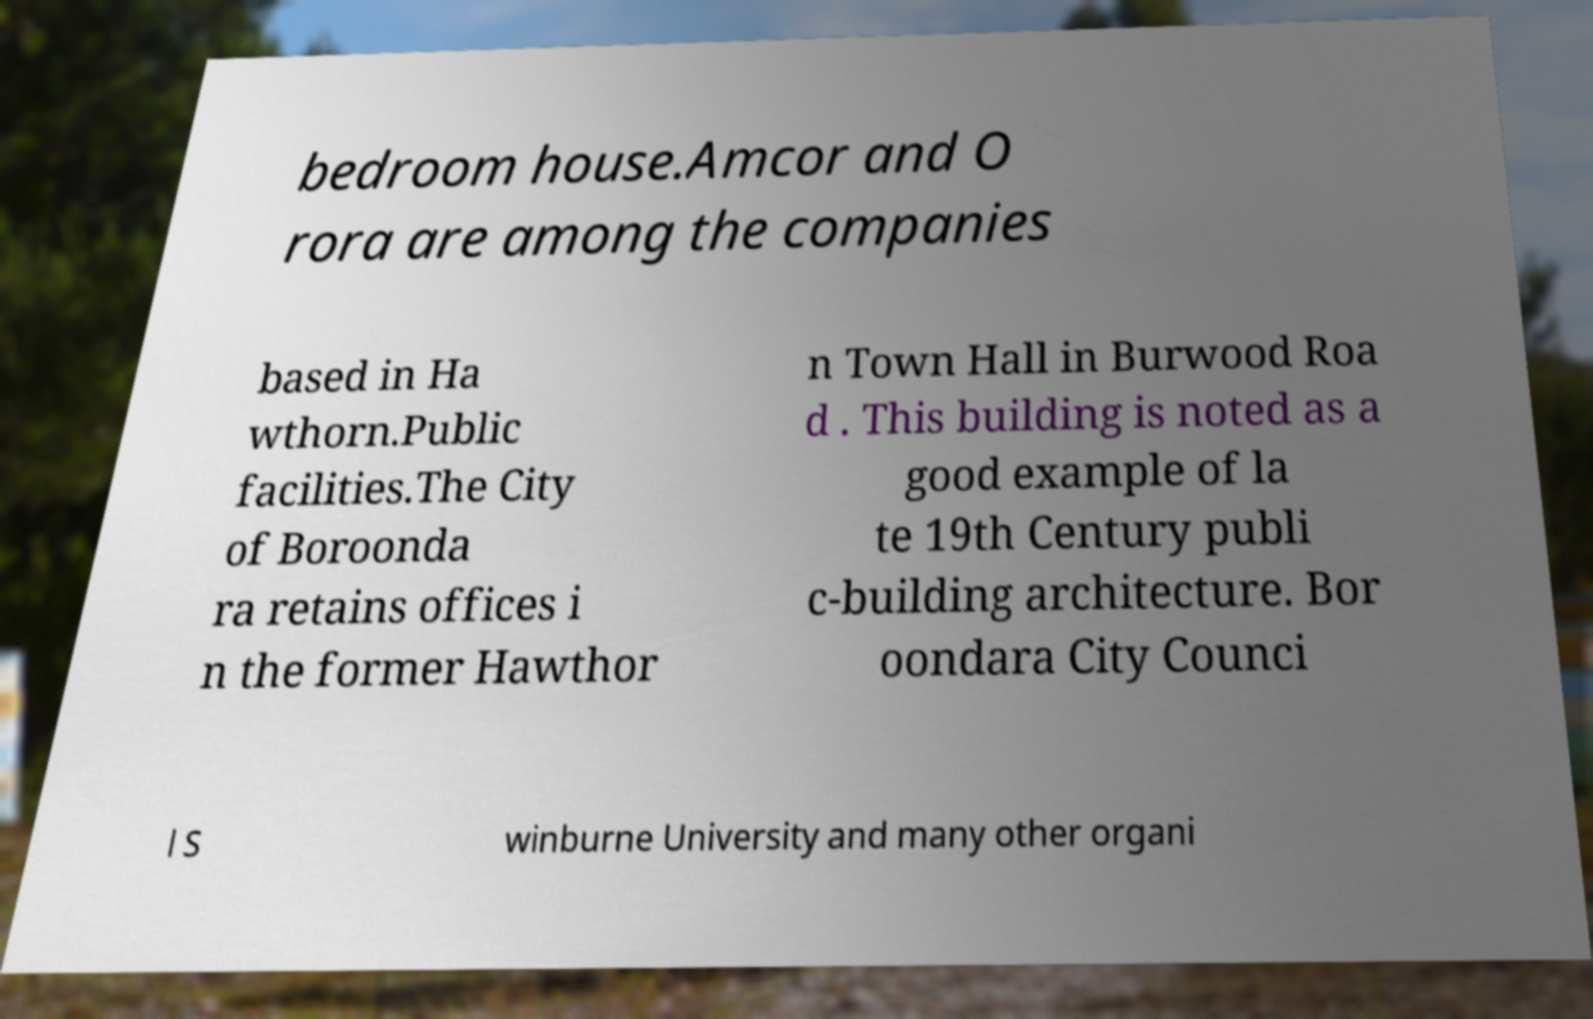There's text embedded in this image that I need extracted. Can you transcribe it verbatim? bedroom house.Amcor and O rora are among the companies based in Ha wthorn.Public facilities.The City of Boroonda ra retains offices i n the former Hawthor n Town Hall in Burwood Roa d . This building is noted as a good example of la te 19th Century publi c-building architecture. Bor oondara City Counci l S winburne University and many other organi 